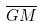<formula> <loc_0><loc_0><loc_500><loc_500>\overline { G M }</formula> 